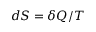Convert formula to latex. <formula><loc_0><loc_0><loc_500><loc_500>d S = \delta Q / T</formula> 